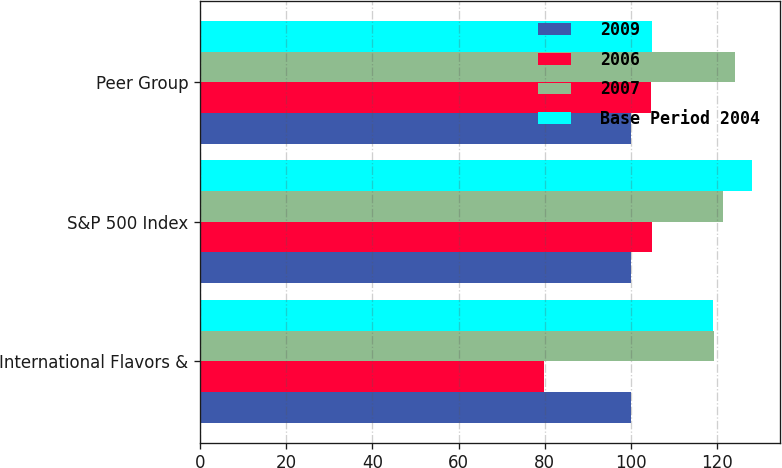Convert chart to OTSL. <chart><loc_0><loc_0><loc_500><loc_500><stacked_bar_chart><ecel><fcel>International Flavors &<fcel>S&P 500 Index<fcel>Peer Group<nl><fcel>2009<fcel>100<fcel>100<fcel>100<nl><fcel>2006<fcel>79.79<fcel>104.91<fcel>104.58<nl><fcel>2007<fcel>119.4<fcel>121.48<fcel>124.09<nl><fcel>Base Period 2004<fcel>118.97<fcel>128.16<fcel>104.91<nl></chart> 